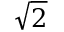Convert formula to latex. <formula><loc_0><loc_0><loc_500><loc_500>\sqrt { 2 }</formula> 